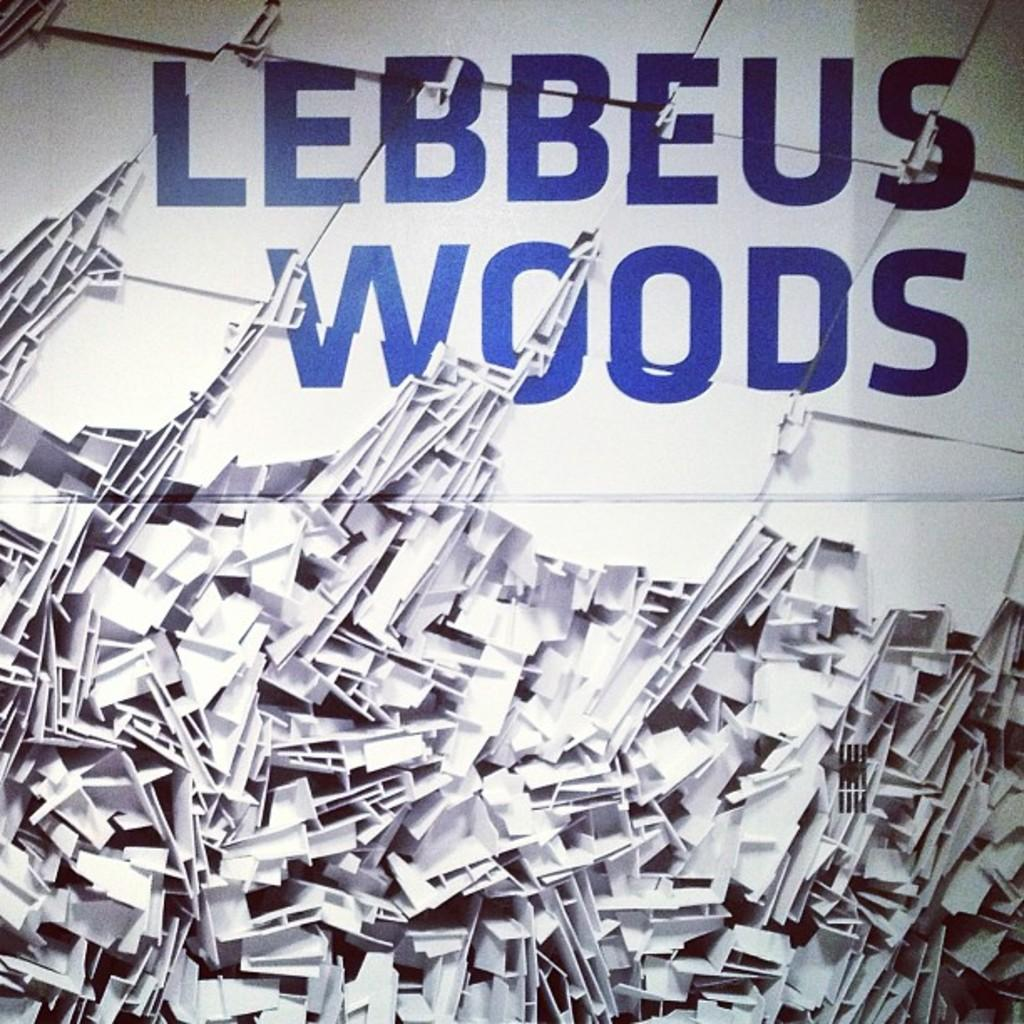<image>
Create a compact narrative representing the image presented. A pile of fragmented white plastic underneath large blue words reading Lebbeus Woods. 